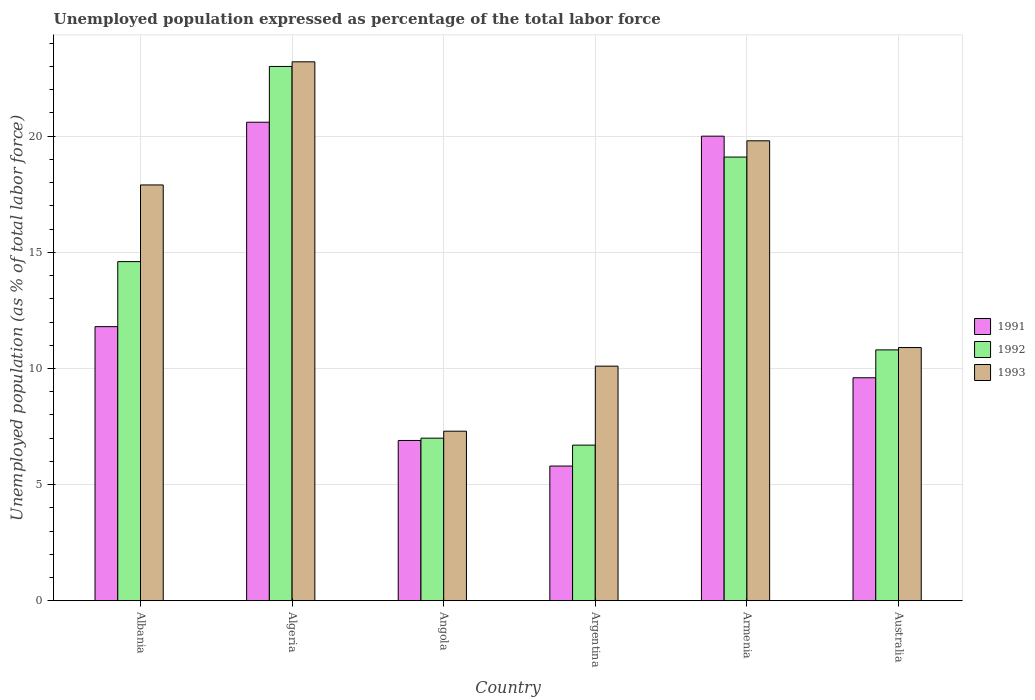How many different coloured bars are there?
Provide a short and direct response. 3. Are the number of bars on each tick of the X-axis equal?
Your answer should be compact. Yes. How many bars are there on the 5th tick from the left?
Provide a succinct answer. 3. How many bars are there on the 2nd tick from the right?
Your answer should be very brief. 3. In how many cases, is the number of bars for a given country not equal to the number of legend labels?
Your response must be concise. 0. What is the unemployment in in 1992 in Argentina?
Your answer should be compact. 6.7. Across all countries, what is the minimum unemployment in in 1991?
Offer a very short reply. 5.8. In which country was the unemployment in in 1991 maximum?
Provide a succinct answer. Algeria. In which country was the unemployment in in 1992 minimum?
Offer a terse response. Argentina. What is the total unemployment in in 1993 in the graph?
Provide a succinct answer. 89.2. What is the difference between the unemployment in in 1993 in Argentina and that in Armenia?
Provide a short and direct response. -9.7. What is the difference between the unemployment in in 1993 in Armenia and the unemployment in in 1992 in Albania?
Offer a terse response. 5.2. What is the average unemployment in in 1993 per country?
Ensure brevity in your answer.  14.87. What is the difference between the unemployment in of/in 1993 and unemployment in of/in 1992 in Australia?
Give a very brief answer. 0.1. In how many countries, is the unemployment in in 1993 greater than 2 %?
Offer a very short reply. 6. What is the ratio of the unemployment in in 1993 in Albania to that in Armenia?
Give a very brief answer. 0.9. Is the difference between the unemployment in in 1993 in Argentina and Armenia greater than the difference between the unemployment in in 1992 in Argentina and Armenia?
Offer a very short reply. Yes. What is the difference between the highest and the second highest unemployment in in 1993?
Give a very brief answer. -1.9. What is the difference between the highest and the lowest unemployment in in 1992?
Your response must be concise. 16.3. In how many countries, is the unemployment in in 1992 greater than the average unemployment in in 1992 taken over all countries?
Give a very brief answer. 3. Is it the case that in every country, the sum of the unemployment in in 1993 and unemployment in in 1991 is greater than the unemployment in in 1992?
Offer a very short reply. Yes. How many bars are there?
Provide a succinct answer. 18. How many countries are there in the graph?
Your answer should be very brief. 6. Does the graph contain any zero values?
Offer a terse response. No. How many legend labels are there?
Offer a very short reply. 3. How are the legend labels stacked?
Give a very brief answer. Vertical. What is the title of the graph?
Your answer should be very brief. Unemployed population expressed as percentage of the total labor force. Does "1970" appear as one of the legend labels in the graph?
Your response must be concise. No. What is the label or title of the Y-axis?
Keep it short and to the point. Unemployed population (as % of total labor force). What is the Unemployed population (as % of total labor force) in 1991 in Albania?
Give a very brief answer. 11.8. What is the Unemployed population (as % of total labor force) in 1992 in Albania?
Your answer should be compact. 14.6. What is the Unemployed population (as % of total labor force) in 1993 in Albania?
Your answer should be very brief. 17.9. What is the Unemployed population (as % of total labor force) of 1991 in Algeria?
Offer a very short reply. 20.6. What is the Unemployed population (as % of total labor force) in 1992 in Algeria?
Offer a terse response. 23. What is the Unemployed population (as % of total labor force) of 1993 in Algeria?
Your answer should be very brief. 23.2. What is the Unemployed population (as % of total labor force) in 1991 in Angola?
Offer a very short reply. 6.9. What is the Unemployed population (as % of total labor force) in 1993 in Angola?
Offer a very short reply. 7.3. What is the Unemployed population (as % of total labor force) in 1991 in Argentina?
Give a very brief answer. 5.8. What is the Unemployed population (as % of total labor force) in 1992 in Argentina?
Your answer should be very brief. 6.7. What is the Unemployed population (as % of total labor force) in 1993 in Argentina?
Your response must be concise. 10.1. What is the Unemployed population (as % of total labor force) in 1992 in Armenia?
Offer a terse response. 19.1. What is the Unemployed population (as % of total labor force) of 1993 in Armenia?
Provide a short and direct response. 19.8. What is the Unemployed population (as % of total labor force) of 1991 in Australia?
Provide a succinct answer. 9.6. What is the Unemployed population (as % of total labor force) in 1992 in Australia?
Your answer should be very brief. 10.8. What is the Unemployed population (as % of total labor force) of 1993 in Australia?
Provide a short and direct response. 10.9. Across all countries, what is the maximum Unemployed population (as % of total labor force) in 1991?
Ensure brevity in your answer.  20.6. Across all countries, what is the maximum Unemployed population (as % of total labor force) in 1992?
Your answer should be very brief. 23. Across all countries, what is the maximum Unemployed population (as % of total labor force) in 1993?
Your answer should be very brief. 23.2. Across all countries, what is the minimum Unemployed population (as % of total labor force) of 1991?
Keep it short and to the point. 5.8. Across all countries, what is the minimum Unemployed population (as % of total labor force) of 1992?
Provide a short and direct response. 6.7. Across all countries, what is the minimum Unemployed population (as % of total labor force) in 1993?
Give a very brief answer. 7.3. What is the total Unemployed population (as % of total labor force) in 1991 in the graph?
Your answer should be compact. 74.7. What is the total Unemployed population (as % of total labor force) of 1992 in the graph?
Offer a terse response. 81.2. What is the total Unemployed population (as % of total labor force) of 1993 in the graph?
Provide a succinct answer. 89.2. What is the difference between the Unemployed population (as % of total labor force) of 1992 in Albania and that in Angola?
Keep it short and to the point. 7.6. What is the difference between the Unemployed population (as % of total labor force) in 1993 in Albania and that in Angola?
Offer a very short reply. 10.6. What is the difference between the Unemployed population (as % of total labor force) of 1991 in Albania and that in Armenia?
Give a very brief answer. -8.2. What is the difference between the Unemployed population (as % of total labor force) in 1992 in Albania and that in Armenia?
Keep it short and to the point. -4.5. What is the difference between the Unemployed population (as % of total labor force) of 1993 in Albania and that in Armenia?
Keep it short and to the point. -1.9. What is the difference between the Unemployed population (as % of total labor force) of 1991 in Albania and that in Australia?
Offer a very short reply. 2.2. What is the difference between the Unemployed population (as % of total labor force) in 1992 in Albania and that in Australia?
Offer a terse response. 3.8. What is the difference between the Unemployed population (as % of total labor force) in 1993 in Albania and that in Australia?
Keep it short and to the point. 7. What is the difference between the Unemployed population (as % of total labor force) of 1993 in Algeria and that in Angola?
Make the answer very short. 15.9. What is the difference between the Unemployed population (as % of total labor force) in 1992 in Algeria and that in Argentina?
Your answer should be very brief. 16.3. What is the difference between the Unemployed population (as % of total labor force) in 1993 in Algeria and that in Argentina?
Your answer should be compact. 13.1. What is the difference between the Unemployed population (as % of total labor force) of 1991 in Algeria and that in Armenia?
Offer a very short reply. 0.6. What is the difference between the Unemployed population (as % of total labor force) in 1991 in Algeria and that in Australia?
Provide a short and direct response. 11. What is the difference between the Unemployed population (as % of total labor force) in 1993 in Algeria and that in Australia?
Your answer should be compact. 12.3. What is the difference between the Unemployed population (as % of total labor force) of 1991 in Angola and that in Argentina?
Give a very brief answer. 1.1. What is the difference between the Unemployed population (as % of total labor force) of 1992 in Angola and that in Argentina?
Your response must be concise. 0.3. What is the difference between the Unemployed population (as % of total labor force) of 1993 in Angola and that in Argentina?
Make the answer very short. -2.8. What is the difference between the Unemployed population (as % of total labor force) in 1993 in Angola and that in Armenia?
Your response must be concise. -12.5. What is the difference between the Unemployed population (as % of total labor force) in 1992 in Angola and that in Australia?
Keep it short and to the point. -3.8. What is the difference between the Unemployed population (as % of total labor force) in 1992 in Argentina and that in Australia?
Your response must be concise. -4.1. What is the difference between the Unemployed population (as % of total labor force) of 1993 in Armenia and that in Australia?
Your answer should be very brief. 8.9. What is the difference between the Unemployed population (as % of total labor force) in 1991 in Albania and the Unemployed population (as % of total labor force) in 1993 in Algeria?
Offer a terse response. -11.4. What is the difference between the Unemployed population (as % of total labor force) of 1992 in Albania and the Unemployed population (as % of total labor force) of 1993 in Algeria?
Provide a succinct answer. -8.6. What is the difference between the Unemployed population (as % of total labor force) in 1992 in Albania and the Unemployed population (as % of total labor force) in 1993 in Angola?
Your response must be concise. 7.3. What is the difference between the Unemployed population (as % of total labor force) of 1991 in Albania and the Unemployed population (as % of total labor force) of 1993 in Argentina?
Ensure brevity in your answer.  1.7. What is the difference between the Unemployed population (as % of total labor force) in 1991 in Albania and the Unemployed population (as % of total labor force) in 1992 in Armenia?
Offer a terse response. -7.3. What is the difference between the Unemployed population (as % of total labor force) of 1991 in Albania and the Unemployed population (as % of total labor force) of 1993 in Armenia?
Your response must be concise. -8. What is the difference between the Unemployed population (as % of total labor force) of 1991 in Albania and the Unemployed population (as % of total labor force) of 1992 in Australia?
Give a very brief answer. 1. What is the difference between the Unemployed population (as % of total labor force) in 1991 in Albania and the Unemployed population (as % of total labor force) in 1993 in Australia?
Make the answer very short. 0.9. What is the difference between the Unemployed population (as % of total labor force) in 1992 in Albania and the Unemployed population (as % of total labor force) in 1993 in Australia?
Ensure brevity in your answer.  3.7. What is the difference between the Unemployed population (as % of total labor force) in 1991 in Algeria and the Unemployed population (as % of total labor force) in 1992 in Angola?
Provide a succinct answer. 13.6. What is the difference between the Unemployed population (as % of total labor force) in 1991 in Algeria and the Unemployed population (as % of total labor force) in 1993 in Angola?
Provide a short and direct response. 13.3. What is the difference between the Unemployed population (as % of total labor force) of 1992 in Algeria and the Unemployed population (as % of total labor force) of 1993 in Angola?
Your answer should be very brief. 15.7. What is the difference between the Unemployed population (as % of total labor force) of 1991 in Algeria and the Unemployed population (as % of total labor force) of 1993 in Argentina?
Your answer should be very brief. 10.5. What is the difference between the Unemployed population (as % of total labor force) in 1991 in Algeria and the Unemployed population (as % of total labor force) in 1992 in Armenia?
Your answer should be compact. 1.5. What is the difference between the Unemployed population (as % of total labor force) in 1991 in Algeria and the Unemployed population (as % of total labor force) in 1993 in Armenia?
Provide a succinct answer. 0.8. What is the difference between the Unemployed population (as % of total labor force) in 1992 in Algeria and the Unemployed population (as % of total labor force) in 1993 in Armenia?
Your response must be concise. 3.2. What is the difference between the Unemployed population (as % of total labor force) of 1991 in Algeria and the Unemployed population (as % of total labor force) of 1993 in Australia?
Provide a short and direct response. 9.7. What is the difference between the Unemployed population (as % of total labor force) of 1992 in Algeria and the Unemployed population (as % of total labor force) of 1993 in Australia?
Your answer should be very brief. 12.1. What is the difference between the Unemployed population (as % of total labor force) of 1991 in Angola and the Unemployed population (as % of total labor force) of 1992 in Argentina?
Provide a succinct answer. 0.2. What is the difference between the Unemployed population (as % of total labor force) in 1991 in Angola and the Unemployed population (as % of total labor force) in 1993 in Argentina?
Your answer should be compact. -3.2. What is the difference between the Unemployed population (as % of total labor force) in 1992 in Angola and the Unemployed population (as % of total labor force) in 1993 in Armenia?
Offer a terse response. -12.8. What is the difference between the Unemployed population (as % of total labor force) in 1991 in Angola and the Unemployed population (as % of total labor force) in 1993 in Australia?
Your answer should be compact. -4. What is the difference between the Unemployed population (as % of total labor force) in 1992 in Angola and the Unemployed population (as % of total labor force) in 1993 in Australia?
Provide a short and direct response. -3.9. What is the difference between the Unemployed population (as % of total labor force) of 1991 in Argentina and the Unemployed population (as % of total labor force) of 1992 in Australia?
Make the answer very short. -5. What is the difference between the Unemployed population (as % of total labor force) of 1991 in Argentina and the Unemployed population (as % of total labor force) of 1993 in Australia?
Provide a succinct answer. -5.1. What is the difference between the Unemployed population (as % of total labor force) in 1992 in Argentina and the Unemployed population (as % of total labor force) in 1993 in Australia?
Give a very brief answer. -4.2. What is the difference between the Unemployed population (as % of total labor force) of 1991 in Armenia and the Unemployed population (as % of total labor force) of 1992 in Australia?
Keep it short and to the point. 9.2. What is the difference between the Unemployed population (as % of total labor force) of 1991 in Armenia and the Unemployed population (as % of total labor force) of 1993 in Australia?
Your answer should be very brief. 9.1. What is the average Unemployed population (as % of total labor force) of 1991 per country?
Provide a succinct answer. 12.45. What is the average Unemployed population (as % of total labor force) in 1992 per country?
Offer a very short reply. 13.53. What is the average Unemployed population (as % of total labor force) in 1993 per country?
Your answer should be compact. 14.87. What is the difference between the Unemployed population (as % of total labor force) of 1991 and Unemployed population (as % of total labor force) of 1992 in Algeria?
Provide a short and direct response. -2.4. What is the difference between the Unemployed population (as % of total labor force) in 1991 and Unemployed population (as % of total labor force) in 1993 in Algeria?
Make the answer very short. -2.6. What is the difference between the Unemployed population (as % of total labor force) in 1992 and Unemployed population (as % of total labor force) in 1993 in Algeria?
Provide a succinct answer. -0.2. What is the difference between the Unemployed population (as % of total labor force) in 1991 and Unemployed population (as % of total labor force) in 1993 in Argentina?
Your response must be concise. -4.3. What is the difference between the Unemployed population (as % of total labor force) of 1992 and Unemployed population (as % of total labor force) of 1993 in Armenia?
Your answer should be very brief. -0.7. What is the difference between the Unemployed population (as % of total labor force) of 1991 and Unemployed population (as % of total labor force) of 1993 in Australia?
Provide a succinct answer. -1.3. What is the difference between the Unemployed population (as % of total labor force) of 1992 and Unemployed population (as % of total labor force) of 1993 in Australia?
Provide a succinct answer. -0.1. What is the ratio of the Unemployed population (as % of total labor force) of 1991 in Albania to that in Algeria?
Ensure brevity in your answer.  0.57. What is the ratio of the Unemployed population (as % of total labor force) of 1992 in Albania to that in Algeria?
Your answer should be compact. 0.63. What is the ratio of the Unemployed population (as % of total labor force) in 1993 in Albania to that in Algeria?
Provide a succinct answer. 0.77. What is the ratio of the Unemployed population (as % of total labor force) in 1991 in Albania to that in Angola?
Make the answer very short. 1.71. What is the ratio of the Unemployed population (as % of total labor force) of 1992 in Albania to that in Angola?
Provide a succinct answer. 2.09. What is the ratio of the Unemployed population (as % of total labor force) of 1993 in Albania to that in Angola?
Give a very brief answer. 2.45. What is the ratio of the Unemployed population (as % of total labor force) of 1991 in Albania to that in Argentina?
Make the answer very short. 2.03. What is the ratio of the Unemployed population (as % of total labor force) in 1992 in Albania to that in Argentina?
Provide a succinct answer. 2.18. What is the ratio of the Unemployed population (as % of total labor force) of 1993 in Albania to that in Argentina?
Give a very brief answer. 1.77. What is the ratio of the Unemployed population (as % of total labor force) of 1991 in Albania to that in Armenia?
Make the answer very short. 0.59. What is the ratio of the Unemployed population (as % of total labor force) of 1992 in Albania to that in Armenia?
Give a very brief answer. 0.76. What is the ratio of the Unemployed population (as % of total labor force) in 1993 in Albania to that in Armenia?
Your answer should be compact. 0.9. What is the ratio of the Unemployed population (as % of total labor force) of 1991 in Albania to that in Australia?
Your answer should be compact. 1.23. What is the ratio of the Unemployed population (as % of total labor force) of 1992 in Albania to that in Australia?
Ensure brevity in your answer.  1.35. What is the ratio of the Unemployed population (as % of total labor force) of 1993 in Albania to that in Australia?
Your response must be concise. 1.64. What is the ratio of the Unemployed population (as % of total labor force) of 1991 in Algeria to that in Angola?
Keep it short and to the point. 2.99. What is the ratio of the Unemployed population (as % of total labor force) in 1992 in Algeria to that in Angola?
Your response must be concise. 3.29. What is the ratio of the Unemployed population (as % of total labor force) in 1993 in Algeria to that in Angola?
Make the answer very short. 3.18. What is the ratio of the Unemployed population (as % of total labor force) of 1991 in Algeria to that in Argentina?
Your response must be concise. 3.55. What is the ratio of the Unemployed population (as % of total labor force) of 1992 in Algeria to that in Argentina?
Provide a succinct answer. 3.43. What is the ratio of the Unemployed population (as % of total labor force) in 1993 in Algeria to that in Argentina?
Provide a succinct answer. 2.3. What is the ratio of the Unemployed population (as % of total labor force) in 1991 in Algeria to that in Armenia?
Your response must be concise. 1.03. What is the ratio of the Unemployed population (as % of total labor force) of 1992 in Algeria to that in Armenia?
Ensure brevity in your answer.  1.2. What is the ratio of the Unemployed population (as % of total labor force) in 1993 in Algeria to that in Armenia?
Ensure brevity in your answer.  1.17. What is the ratio of the Unemployed population (as % of total labor force) in 1991 in Algeria to that in Australia?
Ensure brevity in your answer.  2.15. What is the ratio of the Unemployed population (as % of total labor force) in 1992 in Algeria to that in Australia?
Provide a short and direct response. 2.13. What is the ratio of the Unemployed population (as % of total labor force) in 1993 in Algeria to that in Australia?
Offer a terse response. 2.13. What is the ratio of the Unemployed population (as % of total labor force) in 1991 in Angola to that in Argentina?
Offer a terse response. 1.19. What is the ratio of the Unemployed population (as % of total labor force) of 1992 in Angola to that in Argentina?
Offer a very short reply. 1.04. What is the ratio of the Unemployed population (as % of total labor force) of 1993 in Angola to that in Argentina?
Give a very brief answer. 0.72. What is the ratio of the Unemployed population (as % of total labor force) in 1991 in Angola to that in Armenia?
Give a very brief answer. 0.34. What is the ratio of the Unemployed population (as % of total labor force) in 1992 in Angola to that in Armenia?
Give a very brief answer. 0.37. What is the ratio of the Unemployed population (as % of total labor force) in 1993 in Angola to that in Armenia?
Your answer should be compact. 0.37. What is the ratio of the Unemployed population (as % of total labor force) of 1991 in Angola to that in Australia?
Your response must be concise. 0.72. What is the ratio of the Unemployed population (as % of total labor force) of 1992 in Angola to that in Australia?
Offer a terse response. 0.65. What is the ratio of the Unemployed population (as % of total labor force) in 1993 in Angola to that in Australia?
Keep it short and to the point. 0.67. What is the ratio of the Unemployed population (as % of total labor force) in 1991 in Argentina to that in Armenia?
Ensure brevity in your answer.  0.29. What is the ratio of the Unemployed population (as % of total labor force) in 1992 in Argentina to that in Armenia?
Provide a short and direct response. 0.35. What is the ratio of the Unemployed population (as % of total labor force) in 1993 in Argentina to that in Armenia?
Ensure brevity in your answer.  0.51. What is the ratio of the Unemployed population (as % of total labor force) of 1991 in Argentina to that in Australia?
Offer a terse response. 0.6. What is the ratio of the Unemployed population (as % of total labor force) in 1992 in Argentina to that in Australia?
Keep it short and to the point. 0.62. What is the ratio of the Unemployed population (as % of total labor force) of 1993 in Argentina to that in Australia?
Provide a short and direct response. 0.93. What is the ratio of the Unemployed population (as % of total labor force) in 1991 in Armenia to that in Australia?
Your response must be concise. 2.08. What is the ratio of the Unemployed population (as % of total labor force) in 1992 in Armenia to that in Australia?
Offer a very short reply. 1.77. What is the ratio of the Unemployed population (as % of total labor force) of 1993 in Armenia to that in Australia?
Give a very brief answer. 1.82. What is the difference between the highest and the second highest Unemployed population (as % of total labor force) of 1991?
Your answer should be very brief. 0.6. What is the difference between the highest and the second highest Unemployed population (as % of total labor force) of 1992?
Ensure brevity in your answer.  3.9. What is the difference between the highest and the lowest Unemployed population (as % of total labor force) in 1991?
Keep it short and to the point. 14.8. 